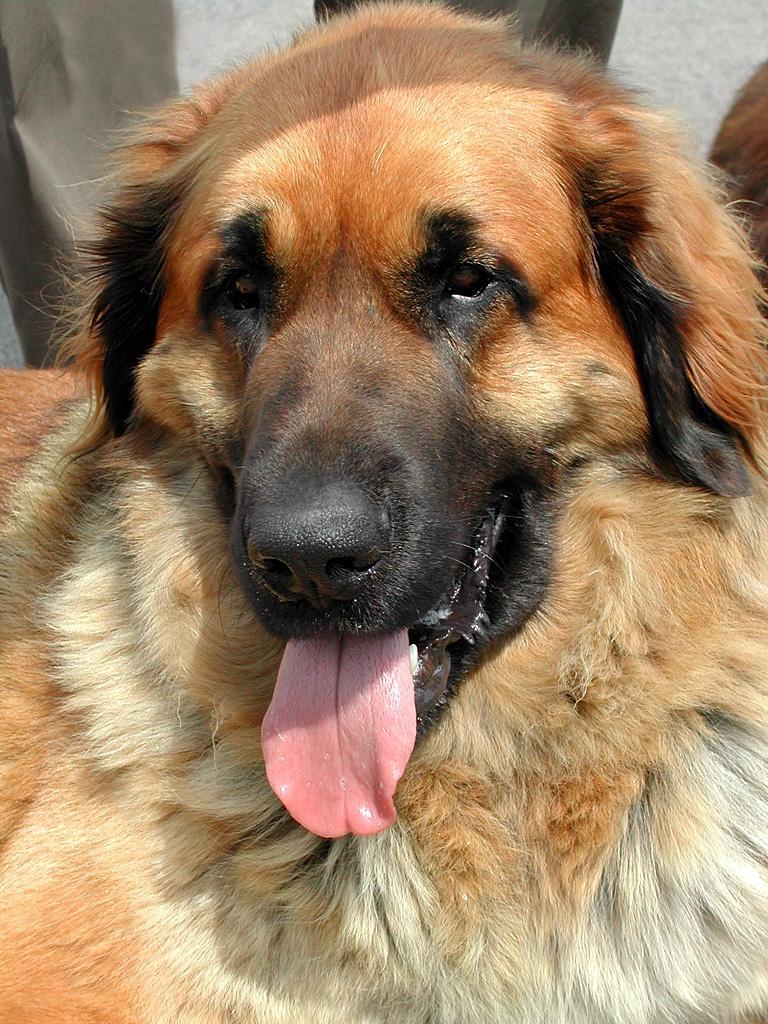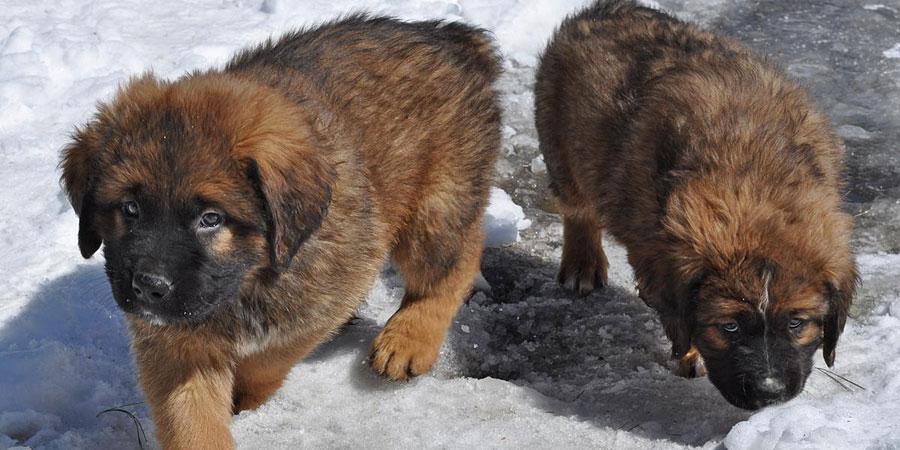The first image is the image on the left, the second image is the image on the right. Given the left and right images, does the statement "An image includes a furry dog lying on green foliage." hold true? Answer yes or no. No. The first image is the image on the left, the second image is the image on the right. Evaluate the accuracy of this statement regarding the images: "There are three or more dogs.". Is it true? Answer yes or no. Yes. 